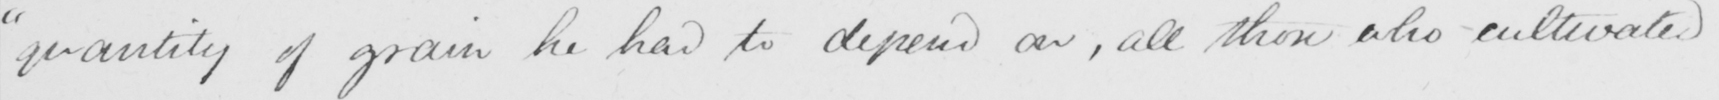Can you tell me what this handwritten text says? "quantity of grain he had to depend on, all those who cultivated 